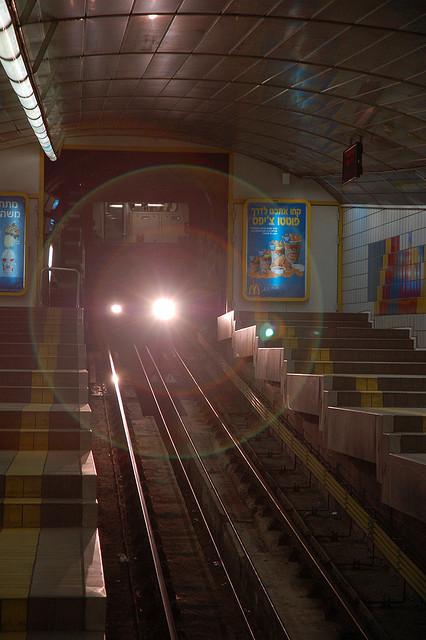Is this taken underground?
Be succinct. Yes. How many lights are on?
Short answer required. 2. Are there people in the image?
Give a very brief answer. No. 